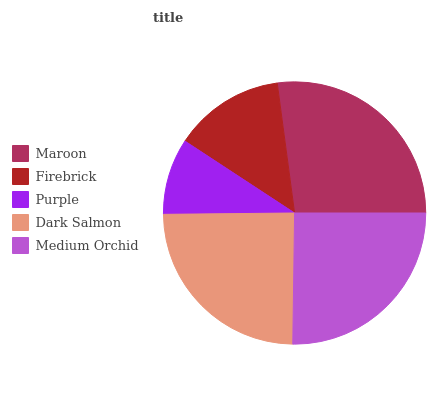Is Purple the minimum?
Answer yes or no. Yes. Is Maroon the maximum?
Answer yes or no. Yes. Is Firebrick the minimum?
Answer yes or no. No. Is Firebrick the maximum?
Answer yes or no. No. Is Maroon greater than Firebrick?
Answer yes or no. Yes. Is Firebrick less than Maroon?
Answer yes or no. Yes. Is Firebrick greater than Maroon?
Answer yes or no. No. Is Maroon less than Firebrick?
Answer yes or no. No. Is Dark Salmon the high median?
Answer yes or no. Yes. Is Dark Salmon the low median?
Answer yes or no. Yes. Is Maroon the high median?
Answer yes or no. No. Is Purple the low median?
Answer yes or no. No. 